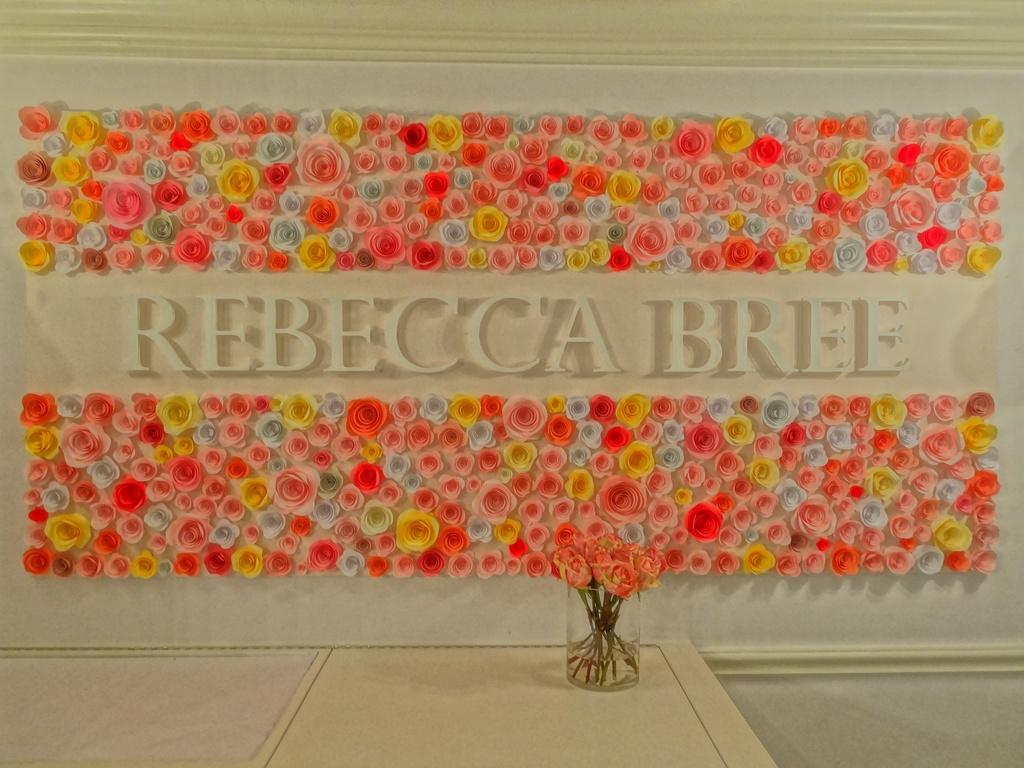What can be seen on the wall in the image? The wall is decorated with flowers in the image. What is the purpose of the glass container in the image? The glass container contains flowers in the image. What type of vegetable is growing on the wall in the image? There are no vegetables present in the image; the wall is decorated with flowers. Can you tell me how many calculators are visible in the image? There are no calculators present in the image. 